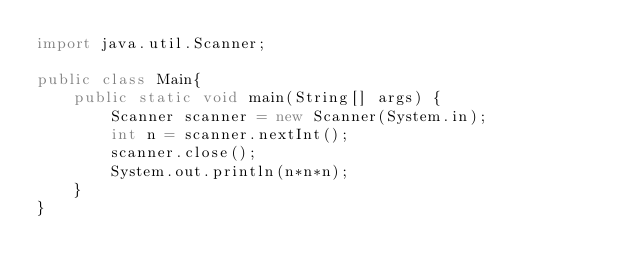<code> <loc_0><loc_0><loc_500><loc_500><_Java_>import java.util.Scanner;
 
public class Main{
    public static void main(String[] args) {
        Scanner scanner = new Scanner(System.in);
        int n = scanner.nextInt();
        scanner.close();
        System.out.println(n*n*n);
    }
}
</code> 